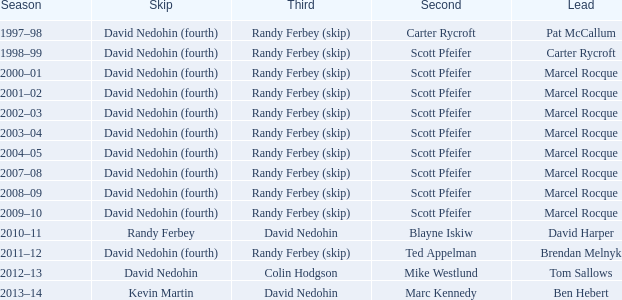Which Third has a Second of scott pfeifer? Randy Ferbey (skip), Randy Ferbey (skip), Randy Ferbey (skip), Randy Ferbey (skip), Randy Ferbey (skip), Randy Ferbey (skip), Randy Ferbey (skip), Randy Ferbey (skip), Randy Ferbey (skip). 